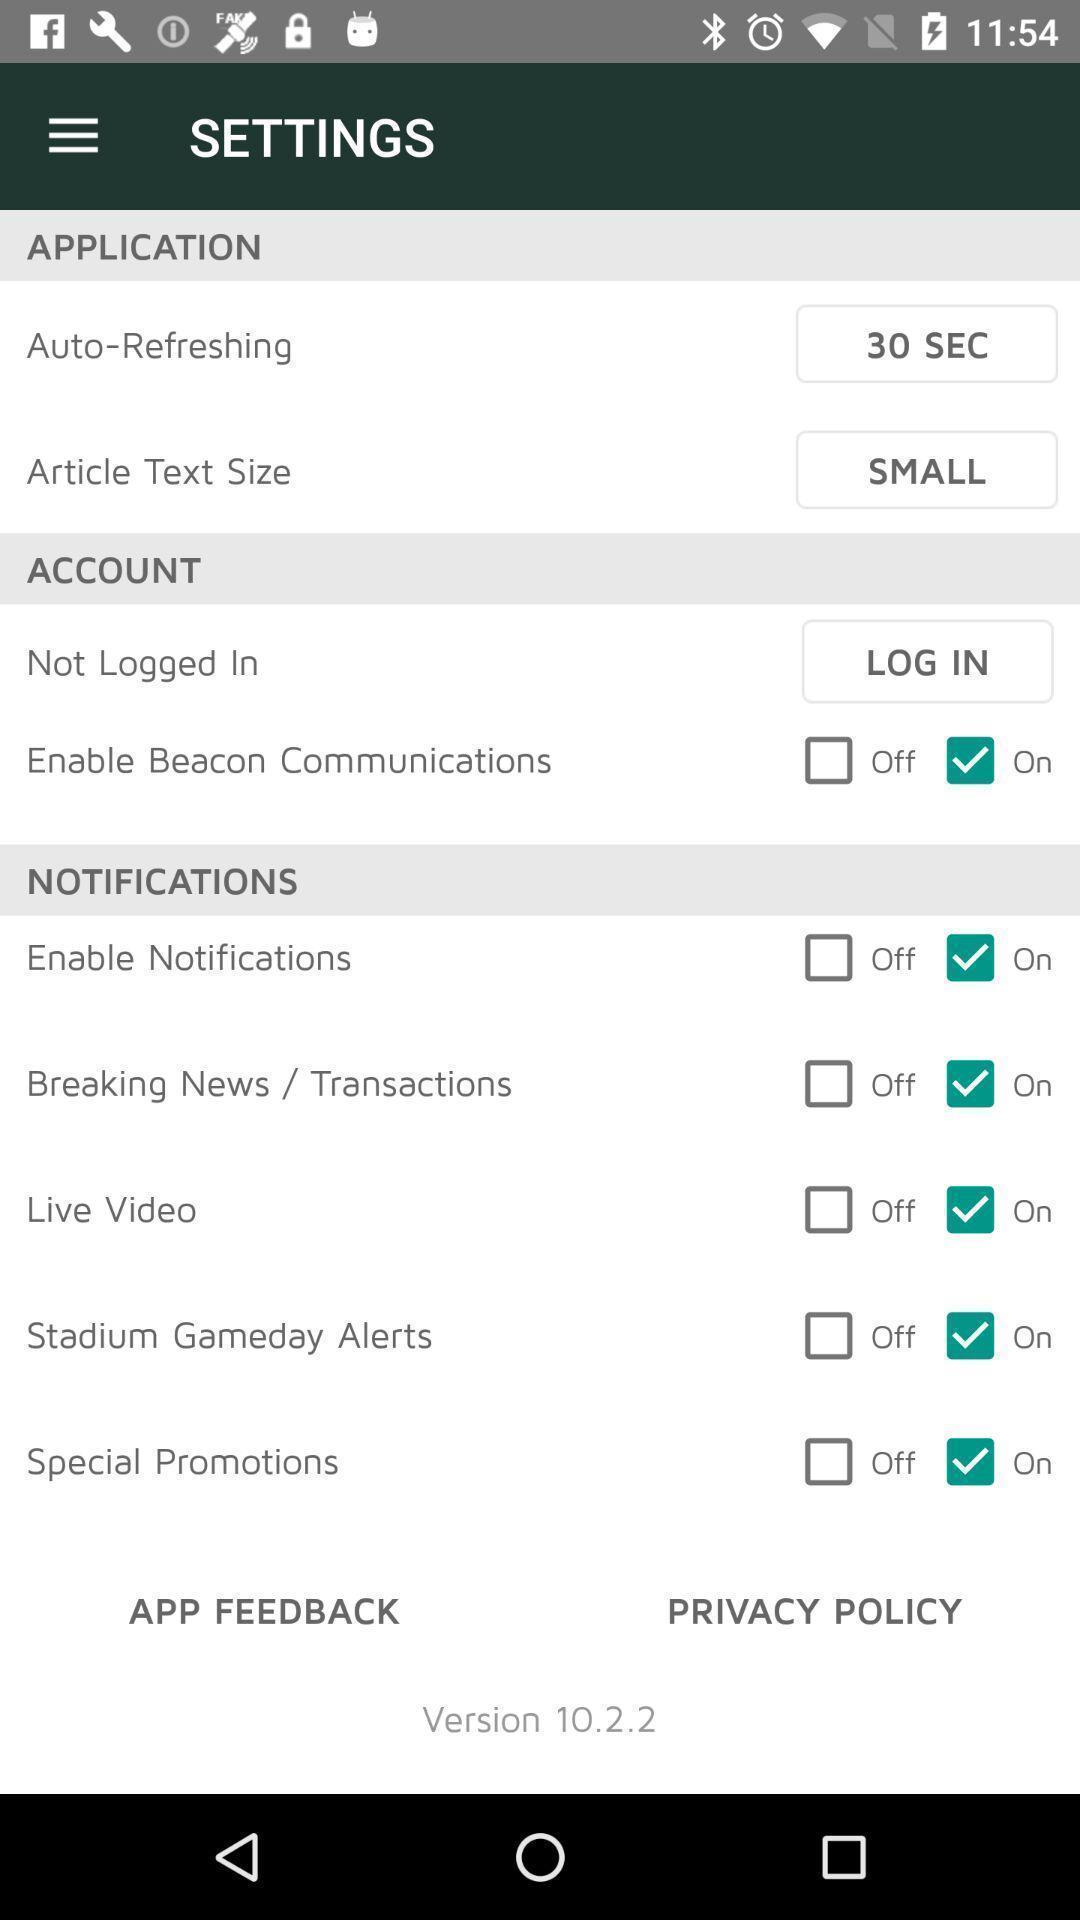What is the overall content of this screenshot? Settings tabs in application with different option. 